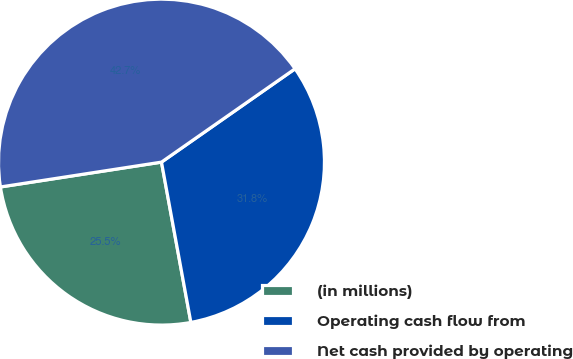Convert chart. <chart><loc_0><loc_0><loc_500><loc_500><pie_chart><fcel>(in millions)<fcel>Operating cash flow from<fcel>Net cash provided by operating<nl><fcel>25.45%<fcel>31.82%<fcel>42.73%<nl></chart> 